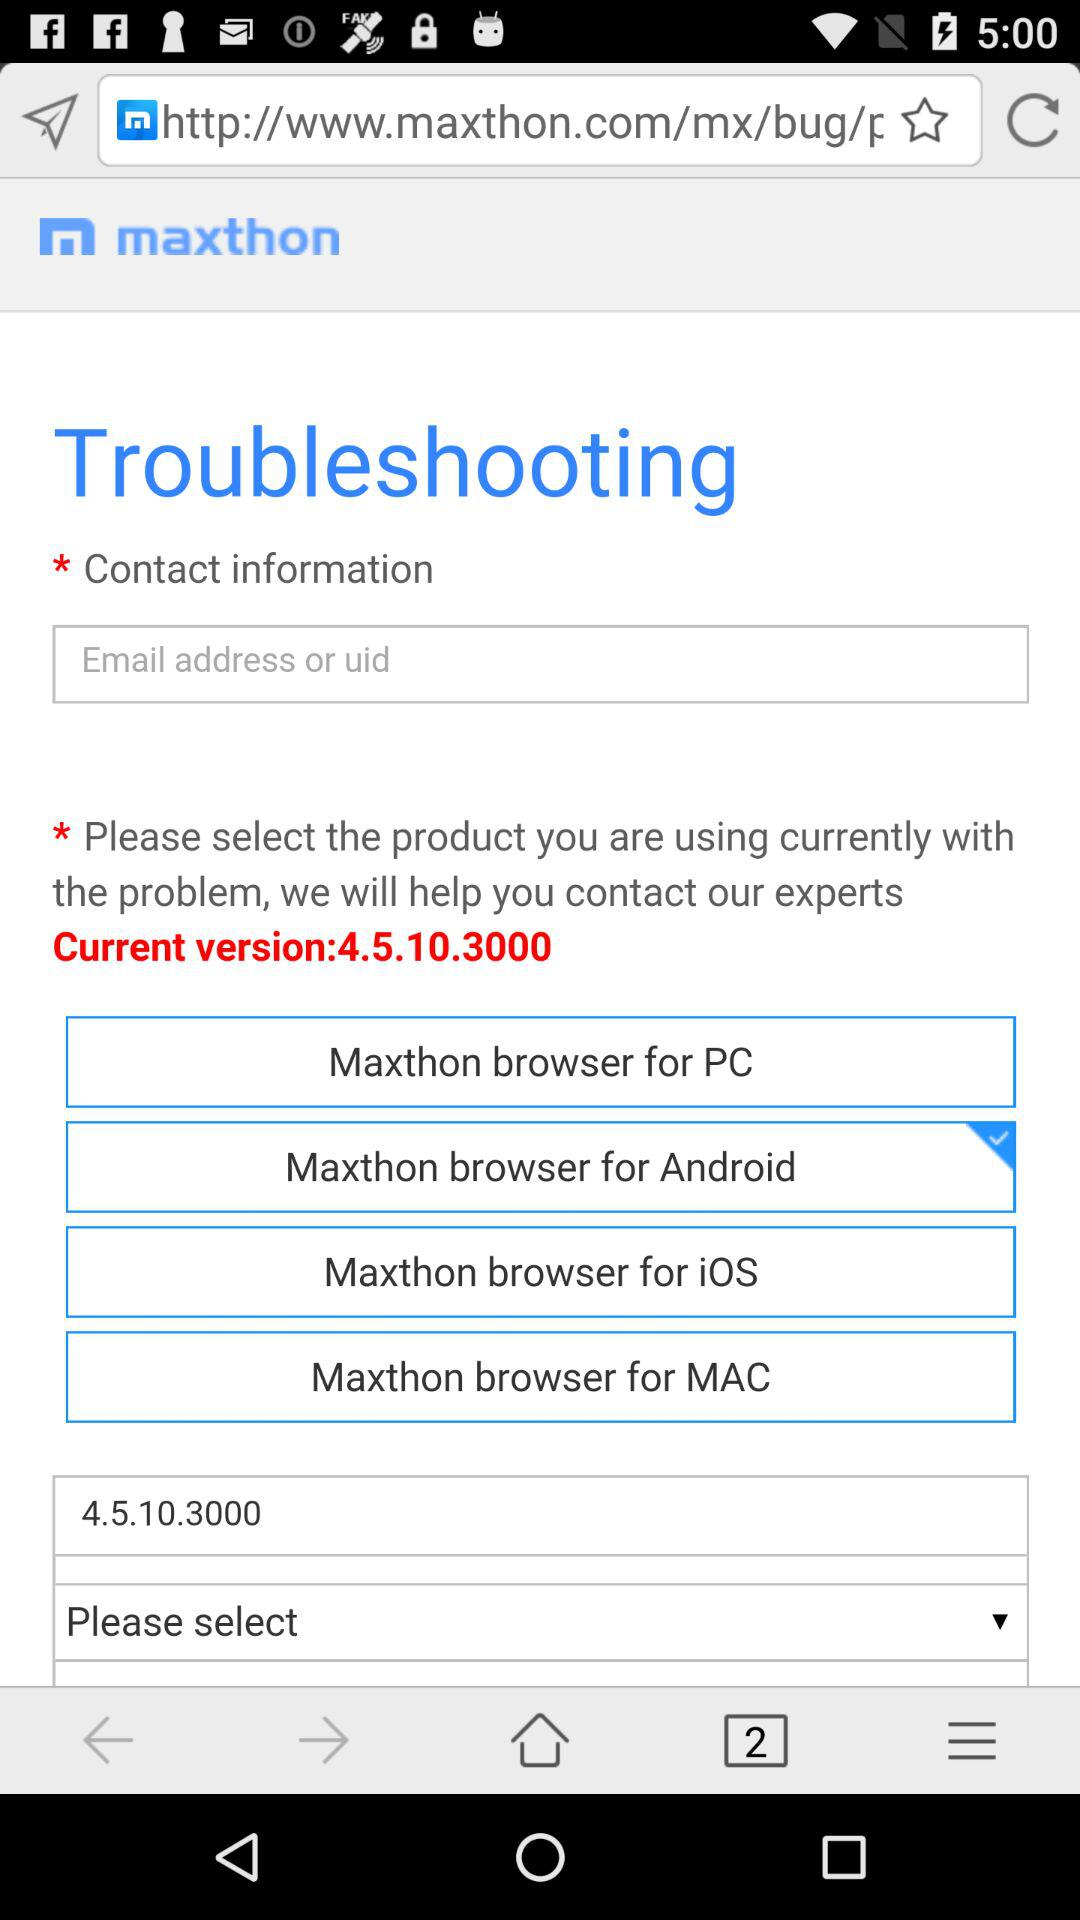How many product options are there?
Answer the question using a single word or phrase. 4 